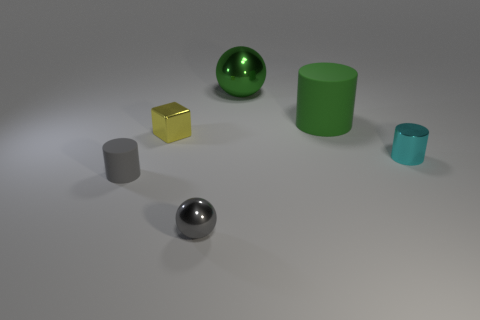Is the small gray ball made of the same material as the large green cylinder?
Your answer should be compact. No. There is a metallic thing that is in front of the tiny yellow shiny thing and on the left side of the green cylinder; what size is it?
Give a very brief answer. Small. The gray matte object that is the same size as the cyan cylinder is what shape?
Your response must be concise. Cylinder. The sphere in front of the small object that is on the right side of the green metal ball that is left of the tiny cyan shiny cylinder is made of what material?
Give a very brief answer. Metal. There is a small metal thing on the right side of the tiny shiny sphere; is it the same shape as the rubber object that is behind the tiny cyan metal cylinder?
Keep it short and to the point. Yes. How many other objects are there of the same material as the gray cylinder?
Provide a succinct answer. 1. Do the tiny cylinder that is left of the cyan metal object and the sphere that is behind the tiny matte cylinder have the same material?
Provide a short and direct response. No. There is a cyan object that is the same material as the small gray ball; what shape is it?
Offer a terse response. Cylinder. Is there any other thing of the same color as the small sphere?
Provide a short and direct response. Yes. What number of big green matte balls are there?
Your answer should be compact. 0. 